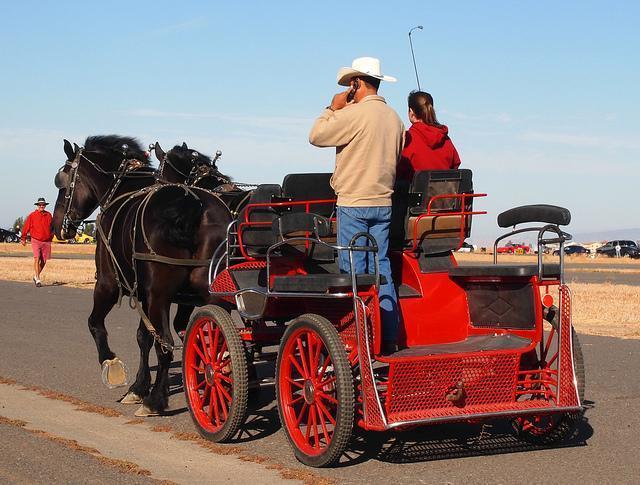How many horses are in the photo?
Give a very brief answer. 2. How many girls are visible?
Give a very brief answer. 1. How many horses are pulling the carriage?
Give a very brief answer. 2. How many people can you see?
Give a very brief answer. 2. How many horses are there?
Give a very brief answer. 2. How many chairs are in the picture?
Give a very brief answer. 3. 